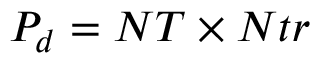<formula> <loc_0><loc_0><loc_500><loc_500>P _ { d } = N T \times N t r</formula> 